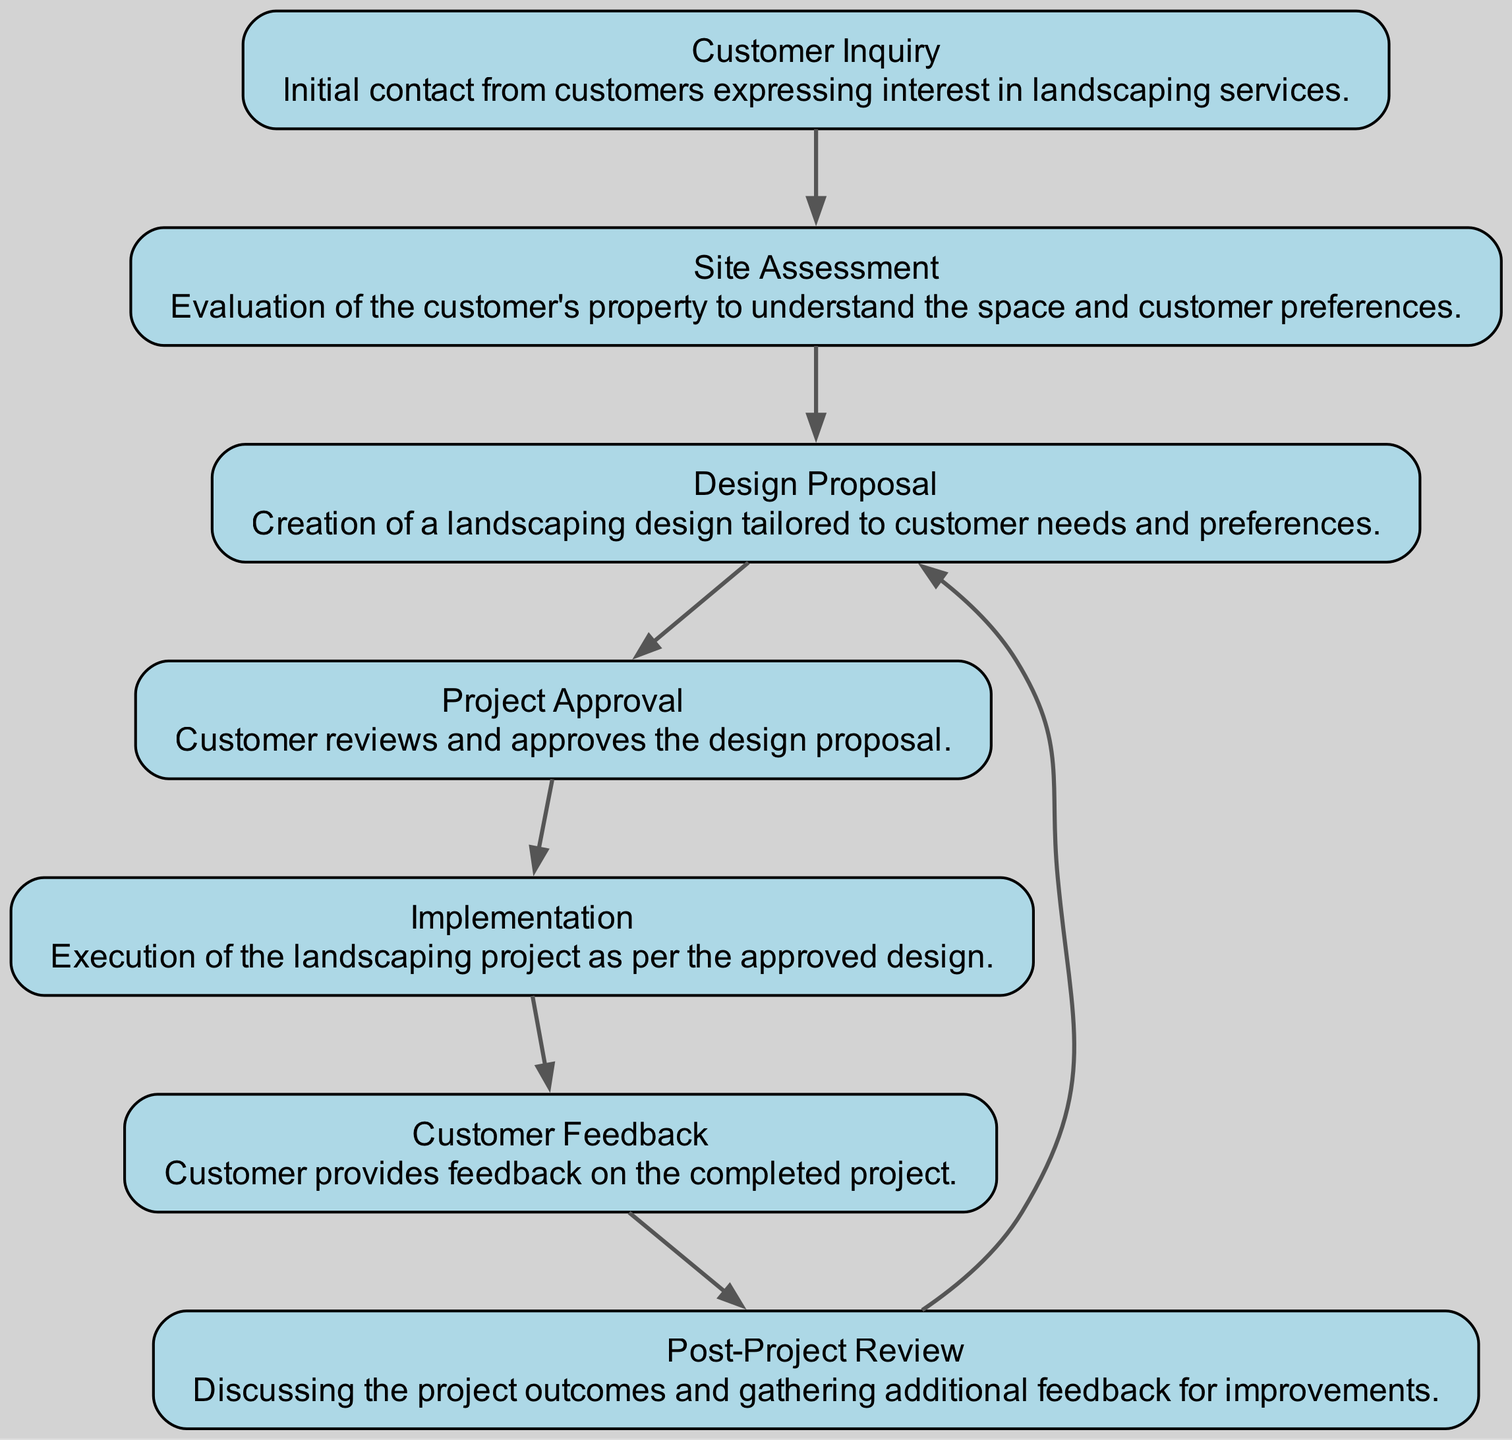What is the first step in the process? The diagram shows that the first node is "Customer Inquiry," indicating that the process starts with initial contact from customers.
Answer: Customer Inquiry How many nodes are present in the diagram? By counting each unique node listed, we find there are 7 nodes total in the diagram.
Answer: 7 What node comes after "Design Proposal"? The directed edge leads from "Design Proposal" to "Project Approval," indicating that "Project Approval" is the next step.
Answer: Project Approval Which step requires customer approval before moving forward? The flow indicates that "Project Approval" must be completed before advancing to the next step, which is "Implementation."
Answer: Project Approval What feedback is collected after project implementation? The "Customer Feedback" node follows "Implementation," which is when feedback is gathered regarding the completed project.
Answer: Customer Feedback How many edges connect the nodes in this diagram? Counting all the directed connections (edges) listed, there are 6 edges that connect the nodes in the diagram.
Answer: 6 What process is revisited after the "Post-Project Review"? The edge leading from "Post-Project Review" back to "Design Proposal" indicates that this design may be revisited for future improvements.
Answer: Design Proposal Which node represents the evaluation of the customer's property? The diagram specifies "Site Assessment" as the node responsible for evaluating the customer's property.
Answer: Site Assessment What describes the relationship between "Customer Feedback" and "Post-Project Review"? The directed edge connects "Customer Feedback" to "Post-Project Review" indicating that feedback is discussed in the review process.
Answer: Discussing feedback 